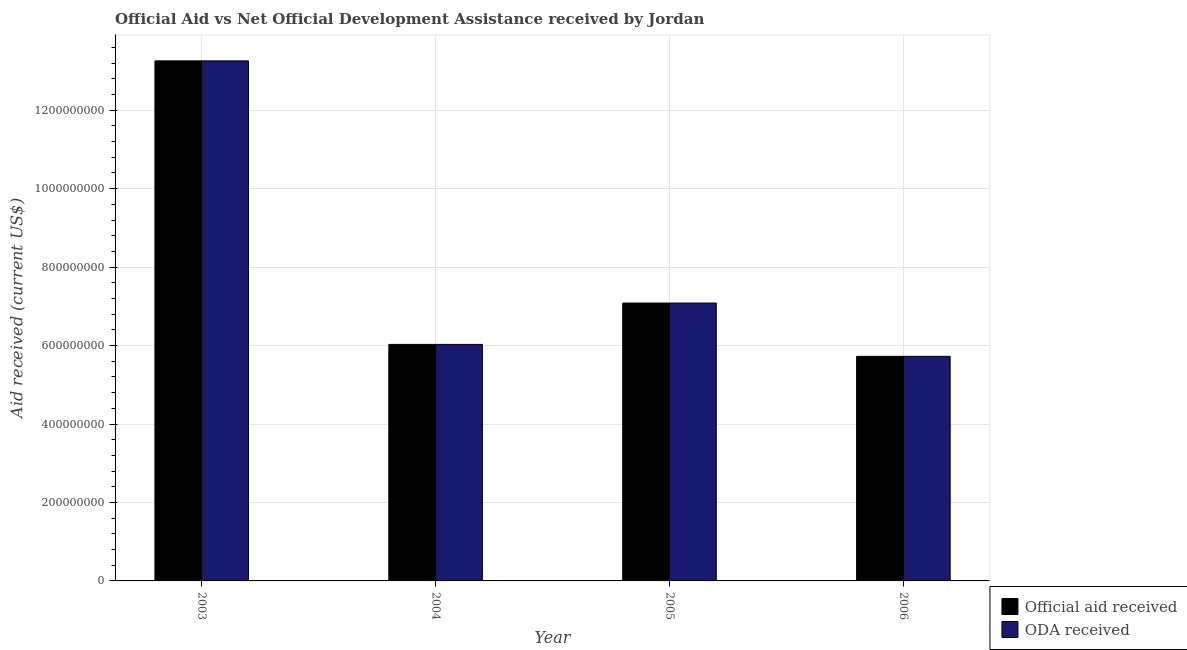How many different coloured bars are there?
Ensure brevity in your answer.  2. Are the number of bars per tick equal to the number of legend labels?
Ensure brevity in your answer.  Yes. What is the label of the 4th group of bars from the left?
Ensure brevity in your answer.  2006. What is the official aid received in 2005?
Provide a succinct answer. 7.08e+08. Across all years, what is the maximum official aid received?
Provide a short and direct response. 1.33e+09. Across all years, what is the minimum oda received?
Your response must be concise. 5.73e+08. In which year was the official aid received maximum?
Ensure brevity in your answer.  2003. In which year was the official aid received minimum?
Make the answer very short. 2006. What is the total official aid received in the graph?
Your answer should be compact. 3.21e+09. What is the difference between the oda received in 2005 and that in 2006?
Give a very brief answer. 1.36e+08. What is the difference between the oda received in 2006 and the official aid received in 2004?
Give a very brief answer. -3.04e+07. What is the average official aid received per year?
Keep it short and to the point. 8.02e+08. In the year 2005, what is the difference between the oda received and official aid received?
Ensure brevity in your answer.  0. In how many years, is the oda received greater than 480000000 US$?
Your answer should be very brief. 4. What is the ratio of the official aid received in 2004 to that in 2005?
Your answer should be very brief. 0.85. Is the difference between the official aid received in 2005 and 2006 greater than the difference between the oda received in 2005 and 2006?
Offer a very short reply. No. What is the difference between the highest and the second highest official aid received?
Keep it short and to the point. 6.17e+08. What is the difference between the highest and the lowest oda received?
Offer a terse response. 7.53e+08. In how many years, is the official aid received greater than the average official aid received taken over all years?
Ensure brevity in your answer.  1. What does the 1st bar from the left in 2005 represents?
Give a very brief answer. Official aid received. What does the 2nd bar from the right in 2006 represents?
Provide a short and direct response. Official aid received. How many bars are there?
Keep it short and to the point. 8. Are all the bars in the graph horizontal?
Offer a very short reply. No. Are the values on the major ticks of Y-axis written in scientific E-notation?
Ensure brevity in your answer.  No. Does the graph contain any zero values?
Offer a terse response. No. Where does the legend appear in the graph?
Offer a terse response. Bottom right. How are the legend labels stacked?
Ensure brevity in your answer.  Vertical. What is the title of the graph?
Make the answer very short. Official Aid vs Net Official Development Assistance received by Jordan . What is the label or title of the X-axis?
Keep it short and to the point. Year. What is the label or title of the Y-axis?
Your answer should be very brief. Aid received (current US$). What is the Aid received (current US$) of Official aid received in 2003?
Offer a very short reply. 1.33e+09. What is the Aid received (current US$) of ODA received in 2003?
Give a very brief answer. 1.33e+09. What is the Aid received (current US$) of Official aid received in 2004?
Ensure brevity in your answer.  6.03e+08. What is the Aid received (current US$) in ODA received in 2004?
Your response must be concise. 6.03e+08. What is the Aid received (current US$) of Official aid received in 2005?
Give a very brief answer. 7.08e+08. What is the Aid received (current US$) in ODA received in 2005?
Keep it short and to the point. 7.08e+08. What is the Aid received (current US$) in Official aid received in 2006?
Make the answer very short. 5.73e+08. What is the Aid received (current US$) of ODA received in 2006?
Offer a terse response. 5.73e+08. Across all years, what is the maximum Aid received (current US$) of Official aid received?
Offer a very short reply. 1.33e+09. Across all years, what is the maximum Aid received (current US$) in ODA received?
Give a very brief answer. 1.33e+09. Across all years, what is the minimum Aid received (current US$) in Official aid received?
Your answer should be very brief. 5.73e+08. Across all years, what is the minimum Aid received (current US$) in ODA received?
Provide a short and direct response. 5.73e+08. What is the total Aid received (current US$) of Official aid received in the graph?
Keep it short and to the point. 3.21e+09. What is the total Aid received (current US$) in ODA received in the graph?
Ensure brevity in your answer.  3.21e+09. What is the difference between the Aid received (current US$) in Official aid received in 2003 and that in 2004?
Provide a succinct answer. 7.23e+08. What is the difference between the Aid received (current US$) in ODA received in 2003 and that in 2004?
Your answer should be compact. 7.23e+08. What is the difference between the Aid received (current US$) of Official aid received in 2003 and that in 2005?
Make the answer very short. 6.17e+08. What is the difference between the Aid received (current US$) of ODA received in 2003 and that in 2005?
Offer a terse response. 6.17e+08. What is the difference between the Aid received (current US$) in Official aid received in 2003 and that in 2006?
Your answer should be very brief. 7.53e+08. What is the difference between the Aid received (current US$) of ODA received in 2003 and that in 2006?
Ensure brevity in your answer.  7.53e+08. What is the difference between the Aid received (current US$) in Official aid received in 2004 and that in 2005?
Provide a short and direct response. -1.05e+08. What is the difference between the Aid received (current US$) in ODA received in 2004 and that in 2005?
Make the answer very short. -1.05e+08. What is the difference between the Aid received (current US$) in Official aid received in 2004 and that in 2006?
Your answer should be very brief. 3.04e+07. What is the difference between the Aid received (current US$) in ODA received in 2004 and that in 2006?
Make the answer very short. 3.04e+07. What is the difference between the Aid received (current US$) of Official aid received in 2005 and that in 2006?
Keep it short and to the point. 1.36e+08. What is the difference between the Aid received (current US$) of ODA received in 2005 and that in 2006?
Your response must be concise. 1.36e+08. What is the difference between the Aid received (current US$) of Official aid received in 2003 and the Aid received (current US$) of ODA received in 2004?
Offer a very short reply. 7.23e+08. What is the difference between the Aid received (current US$) of Official aid received in 2003 and the Aid received (current US$) of ODA received in 2005?
Provide a succinct answer. 6.17e+08. What is the difference between the Aid received (current US$) of Official aid received in 2003 and the Aid received (current US$) of ODA received in 2006?
Offer a terse response. 7.53e+08. What is the difference between the Aid received (current US$) in Official aid received in 2004 and the Aid received (current US$) in ODA received in 2005?
Ensure brevity in your answer.  -1.05e+08. What is the difference between the Aid received (current US$) in Official aid received in 2004 and the Aid received (current US$) in ODA received in 2006?
Make the answer very short. 3.04e+07. What is the difference between the Aid received (current US$) of Official aid received in 2005 and the Aid received (current US$) of ODA received in 2006?
Ensure brevity in your answer.  1.36e+08. What is the average Aid received (current US$) in Official aid received per year?
Your response must be concise. 8.02e+08. What is the average Aid received (current US$) of ODA received per year?
Your answer should be compact. 8.02e+08. What is the ratio of the Aid received (current US$) in Official aid received in 2003 to that in 2004?
Offer a terse response. 2.2. What is the ratio of the Aid received (current US$) of ODA received in 2003 to that in 2004?
Offer a very short reply. 2.2. What is the ratio of the Aid received (current US$) of Official aid received in 2003 to that in 2005?
Offer a terse response. 1.87. What is the ratio of the Aid received (current US$) of ODA received in 2003 to that in 2005?
Provide a short and direct response. 1.87. What is the ratio of the Aid received (current US$) in Official aid received in 2003 to that in 2006?
Make the answer very short. 2.32. What is the ratio of the Aid received (current US$) of ODA received in 2003 to that in 2006?
Keep it short and to the point. 2.32. What is the ratio of the Aid received (current US$) of Official aid received in 2004 to that in 2005?
Your answer should be very brief. 0.85. What is the ratio of the Aid received (current US$) of ODA received in 2004 to that in 2005?
Your response must be concise. 0.85. What is the ratio of the Aid received (current US$) of Official aid received in 2004 to that in 2006?
Your answer should be compact. 1.05. What is the ratio of the Aid received (current US$) in ODA received in 2004 to that in 2006?
Offer a terse response. 1.05. What is the ratio of the Aid received (current US$) in Official aid received in 2005 to that in 2006?
Provide a succinct answer. 1.24. What is the ratio of the Aid received (current US$) in ODA received in 2005 to that in 2006?
Offer a very short reply. 1.24. What is the difference between the highest and the second highest Aid received (current US$) of Official aid received?
Offer a very short reply. 6.17e+08. What is the difference between the highest and the second highest Aid received (current US$) in ODA received?
Your answer should be compact. 6.17e+08. What is the difference between the highest and the lowest Aid received (current US$) in Official aid received?
Your answer should be very brief. 7.53e+08. What is the difference between the highest and the lowest Aid received (current US$) in ODA received?
Make the answer very short. 7.53e+08. 